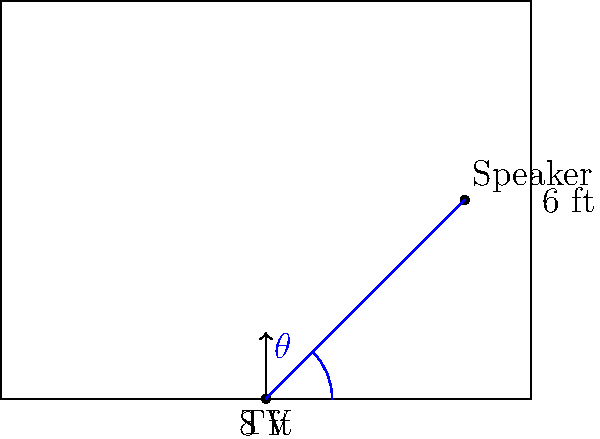In your home theater setup for watching your favorite TV show, you want to place surround sound speakers for optimal audio experience. The room is 8 feet wide and 6 feet deep, with the TV centered on the front wall. If you want to place a speaker on the side wall at a 45° angle from the TV, how far from the front wall should the speaker be placed? Let's approach this step-by-step:

1) First, we need to understand what a 45° angle means in this context. It's the angle between the line from the TV to the speaker and the front wall.

2) We can use the tangent function to solve this problem. The tangent of an angle in a right triangle is the ratio of the opposite side to the adjacent side.

3) In this case:
   - The angle is 45°
   - The adjacent side is the distance from the TV to the side wall (half the room width)
   - The opposite side is the distance we're trying to find

4) Let's call the distance we're looking for $x$.

5) We can set up the equation:
   
   $\tan(45°) = \frac{x}{4}$

6) We know that $\tan(45°) = 1$, so our equation simplifies to:

   $1 = \frac{x}{4}$

7) Solving for $x$:

   $x = 4$ feet

8) Therefore, the speaker should be placed 4 feet from the front wall.

This placement will ensure that the sound from this speaker reaches you at the intended angle, enhancing your TV show viewing experience with optimal surround sound.
Answer: 4 feet 